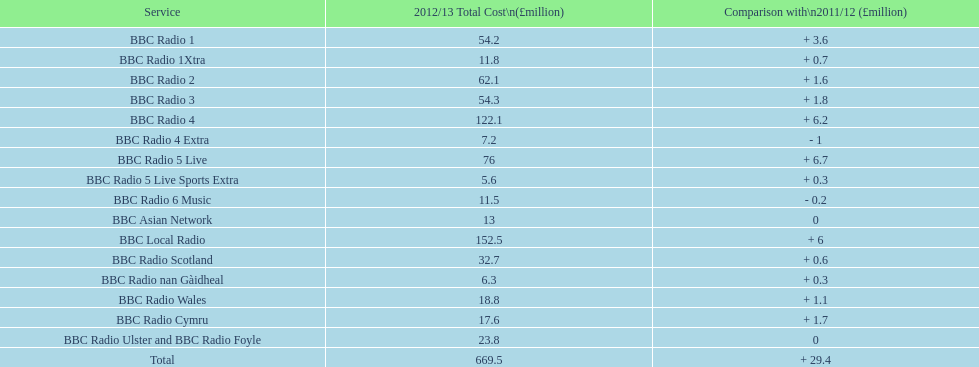Which bbc station had cost the most to run in 2012/13? BBC Local Radio. 